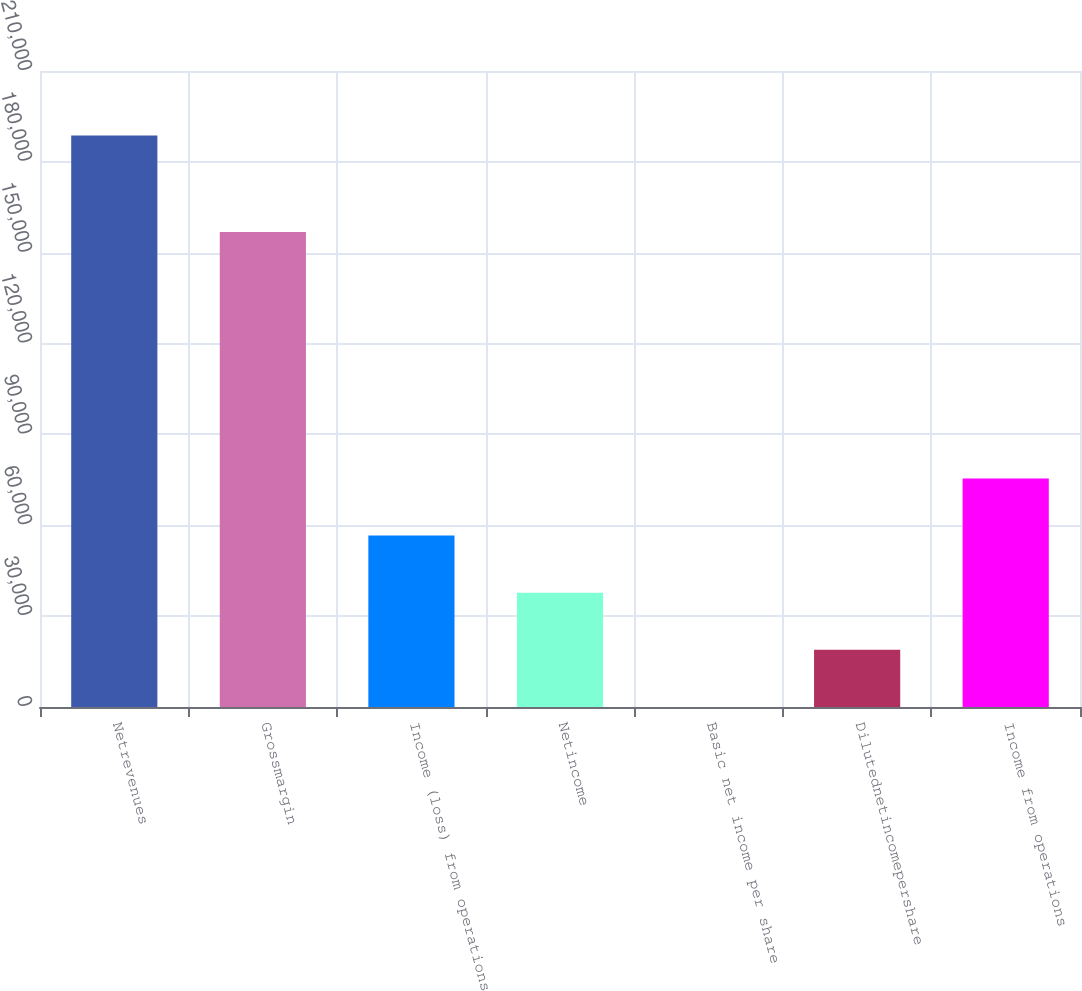Convert chart to OTSL. <chart><loc_0><loc_0><loc_500><loc_500><bar_chart><fcel>Netrevenues<fcel>Grossmargin<fcel>Income (loss) from operations<fcel>Netincome<fcel>Basic net income per share<fcel>Dilutednetincomepershare<fcel>Income from operations<nl><fcel>188701<fcel>156866<fcel>56610.3<fcel>37740.2<fcel>0.03<fcel>18870.1<fcel>75480.4<nl></chart> 